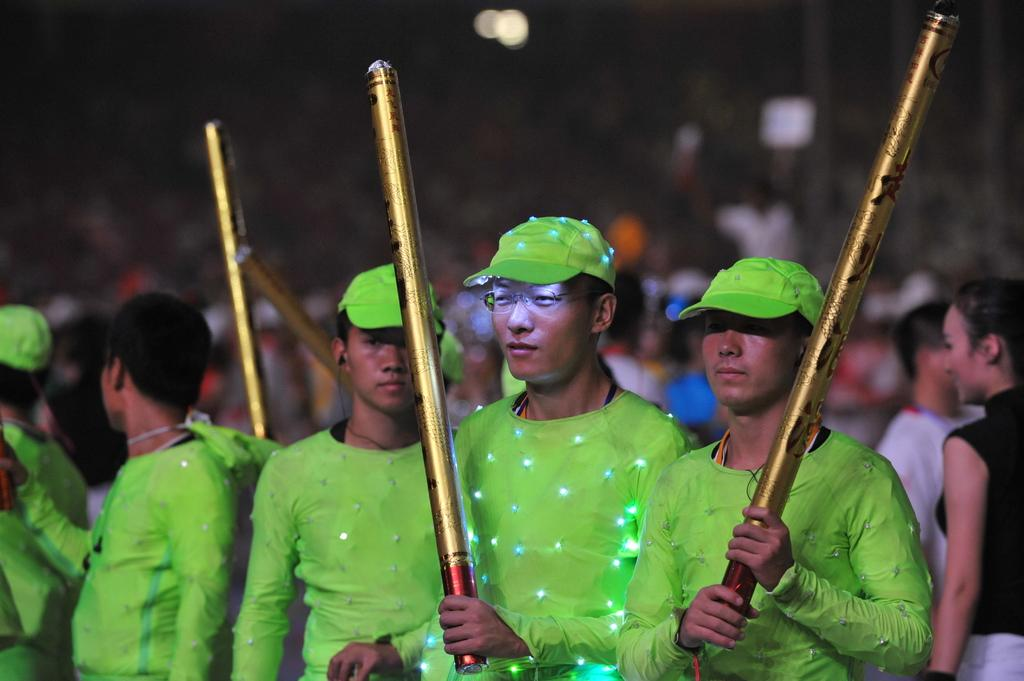How many people are present in the image? There are many people in the image. What accessories are some people wearing in the image? Some people are wearing caps in the image. What objects are some people holding in the image? Some people are holding streamers in the image. Can you describe the background of the image? The background of the image is blurry. What can be seen at the top of the image? There are lights visible at the top of the image. What type of linen is being offered to the people in the image? There is no linen being offered to the people in the image. How many branches are visible in the image? There are no branches visible in the image. 